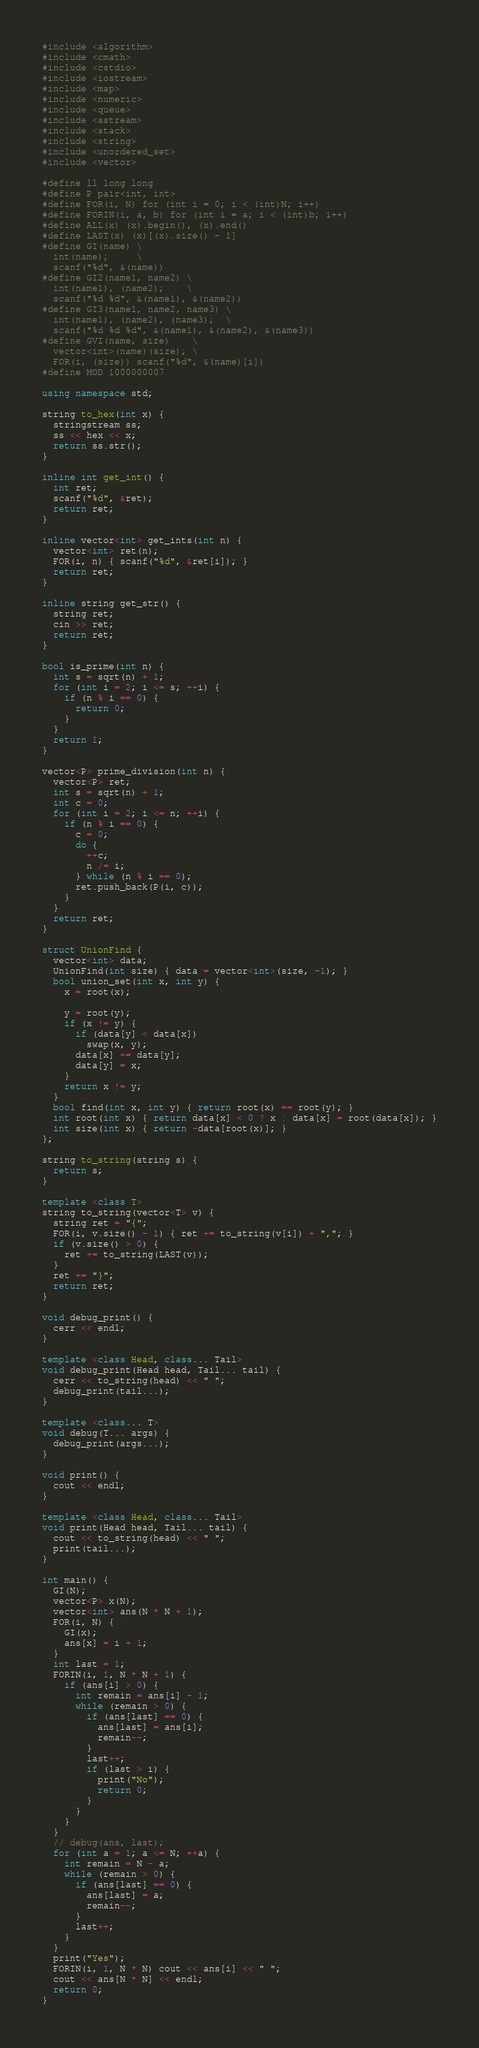<code> <loc_0><loc_0><loc_500><loc_500><_C++_>#include <algorithm>
#include <cmath>
#include <cstdio>
#include <iostream>
#include <map>
#include <numeric>
#include <queue>
#include <sstream>
#include <stack>
#include <string>
#include <unordered_set>
#include <vector>

#define ll long long
#define P pair<int, int>
#define FOR(i, N) for (int i = 0; i < (int)N; i++)
#define FORIN(i, a, b) for (int i = a; i < (int)b; i++)
#define ALL(x) (x).begin(), (x).end()
#define LAST(x) (x)[(x).size() - 1]
#define GI(name) \
  int(name);     \
  scanf("%d", &(name))
#define GI2(name1, name2) \
  int(name1), (name2);    \
  scanf("%d %d", &(name1), &(name2))
#define GI3(name1, name2, name3) \
  int(name1), (name2), (name3);  \
  scanf("%d %d %d", &(name1), &(name2), &(name3))
#define GVI(name, size)    \
  vector<int>(name)(size); \
  FOR(i, (size)) scanf("%d", &(name)[i])
#define MOD 1000000007

using namespace std;

string to_hex(int x) {
  stringstream ss;
  ss << hex << x;
  return ss.str();
}

inline int get_int() {
  int ret;
  scanf("%d", &ret);
  return ret;
}

inline vector<int> get_ints(int n) {
  vector<int> ret(n);
  FOR(i, n) { scanf("%d", &ret[i]); }
  return ret;
}

inline string get_str() {
  string ret;
  cin >> ret;
  return ret;
}

bool is_prime(int n) {
  int s = sqrt(n) + 1;
  for (int i = 2; i <= s; ++i) {
    if (n % i == 0) {
      return 0;
    }
  }
  return 1;
}

vector<P> prime_division(int n) {
  vector<P> ret;
  int s = sqrt(n) + 1;
  int c = 0;
  for (int i = 2; i <= n; ++i) {
    if (n % i == 0) {
      c = 0;
      do {
        ++c;
        n /= i;
      } while (n % i == 0);
      ret.push_back(P(i, c));
    }
  }
  return ret;
}

struct UnionFind {
  vector<int> data;
  UnionFind(int size) { data = vector<int>(size, -1); }
  bool union_set(int x, int y) {
    x = root(x);

    y = root(y);
    if (x != y) {
      if (data[y] < data[x])
        swap(x, y);
      data[x] += data[y];
      data[y] = x;
    }
    return x != y;
  }
  bool find(int x, int y) { return root(x) == root(y); }
  int root(int x) { return data[x] < 0 ? x : data[x] = root(data[x]); }
  int size(int x) { return -data[root(x)]; }
};

string to_string(string s) {
  return s;
}

template <class T>
string to_string(vector<T> v) {
  string ret = "{";
  FOR(i, v.size() - 1) { ret += to_string(v[i]) + ","; }
  if (v.size() > 0) {
    ret += to_string(LAST(v));
  }
  ret += "}";
  return ret;
}

void debug_print() {
  cerr << endl;
}

template <class Head, class... Tail>
void debug_print(Head head, Tail... tail) {
  cerr << to_string(head) << " ";
  debug_print(tail...);
}

template <class... T>
void debug(T... args) {
  debug_print(args...);
}

void print() {
  cout << endl;
}

template <class Head, class... Tail>
void print(Head head, Tail... tail) {
  cout << to_string(head) << " ";
  print(tail...);
}

int main() {
  GI(N);
  vector<P> x(N);
  vector<int> ans(N * N + 1);
  FOR(i, N) {
    GI(x);
    ans[x] = i + 1;
  }
  int last = 1;
  FORIN(i, 1, N * N + 1) {
    if (ans[i] > 0) {
      int remain = ans[i] - 1;
      while (remain > 0) {
        if (ans[last] == 0) {
          ans[last] = ans[i];
          remain--;
        }
        last++;
        if (last > i) {
          print("No");
          return 0;
        }
      }
    }
  }
  // debug(ans, last);
  for (int a = 1; a <= N; ++a) {
    int remain = N - a;
    while (remain > 0) {
      if (ans[last] == 0) {
        ans[last] = a;
        remain--;
      }
      last++;
    }
  }
  print("Yes");
  FORIN(i, 1, N * N) cout << ans[i] << " ";
  cout << ans[N * N] << endl;
  return 0;
}</code> 